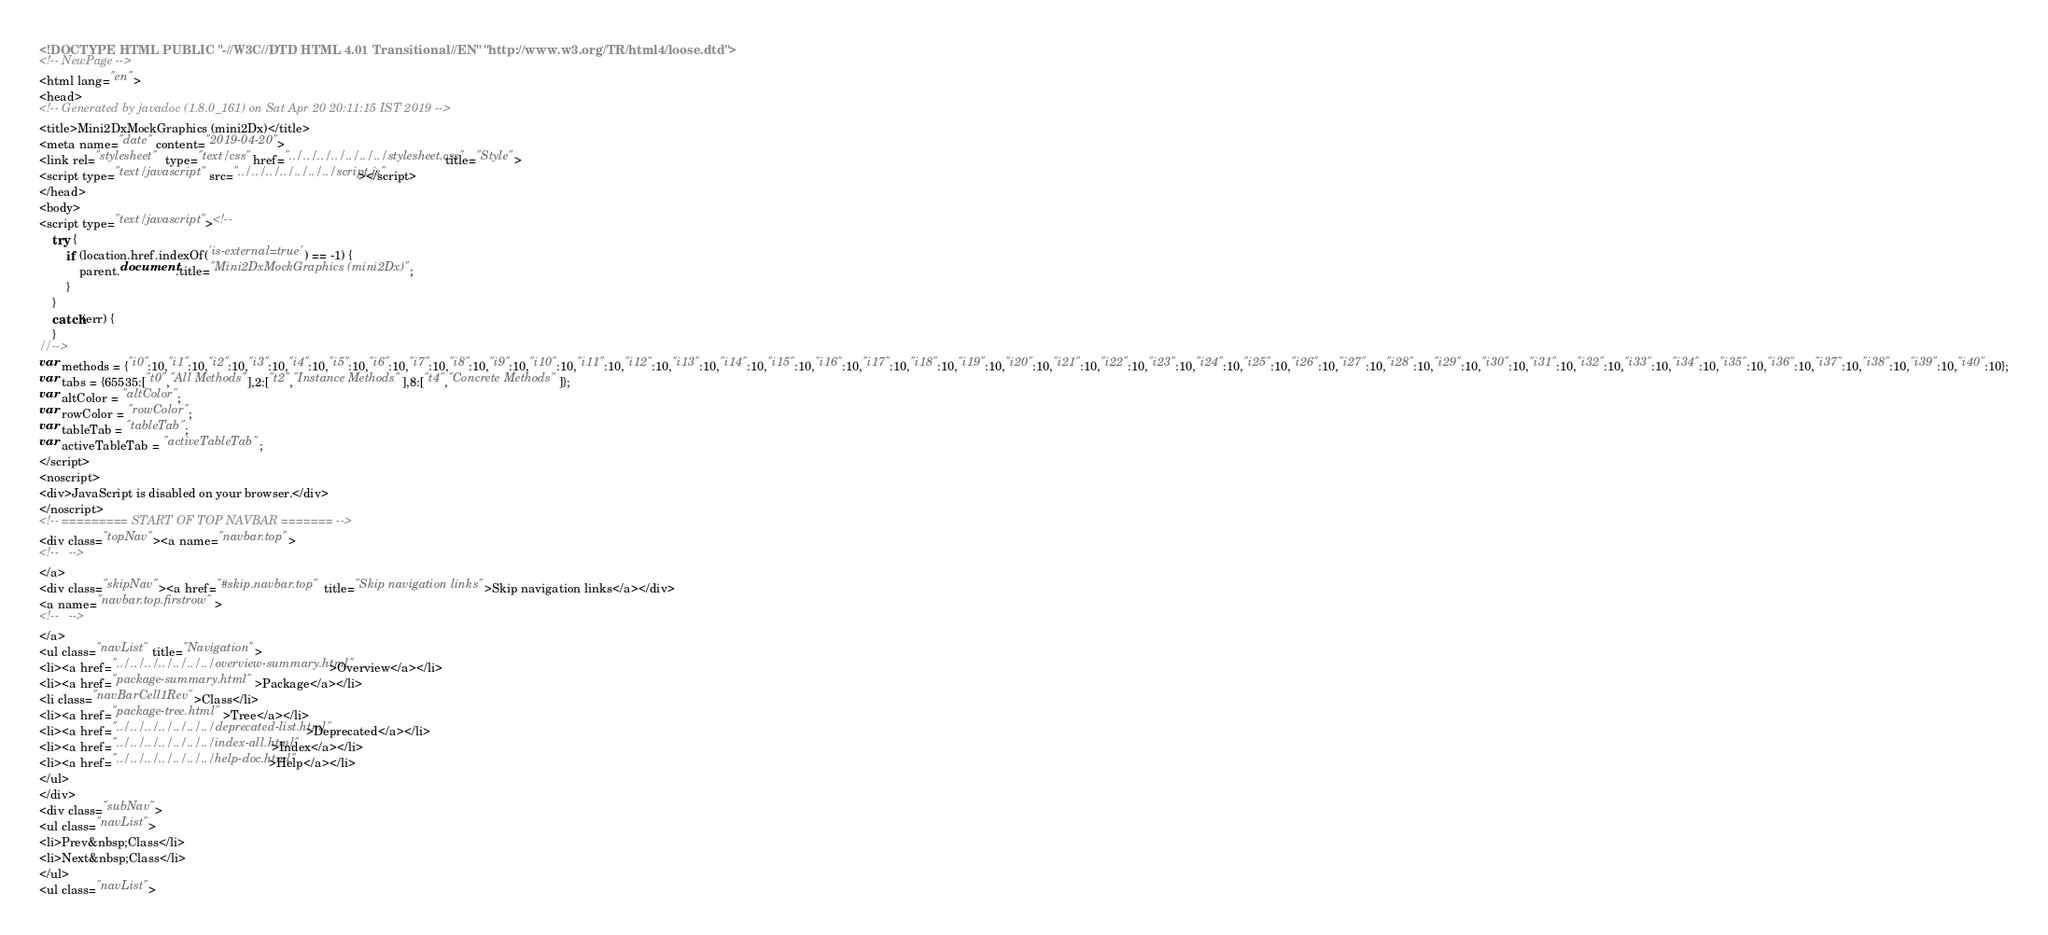Convert code to text. <code><loc_0><loc_0><loc_500><loc_500><_HTML_><!DOCTYPE HTML PUBLIC "-//W3C//DTD HTML 4.01 Transitional//EN" "http://www.w3.org/TR/html4/loose.dtd">
<!-- NewPage -->
<html lang="en">
<head>
<!-- Generated by javadoc (1.8.0_161) on Sat Apr 20 20:11:15 IST 2019 -->
<title>Mini2DxMockGraphics (mini2Dx)</title>
<meta name="date" content="2019-04-20">
<link rel="stylesheet" type="text/css" href="../../../../../../../stylesheet.css" title="Style">
<script type="text/javascript" src="../../../../../../../script.js"></script>
</head>
<body>
<script type="text/javascript"><!--
    try {
        if (location.href.indexOf('is-external=true') == -1) {
            parent.document.title="Mini2DxMockGraphics (mini2Dx)";
        }
    }
    catch(err) {
    }
//-->
var methods = {"i0":10,"i1":10,"i2":10,"i3":10,"i4":10,"i5":10,"i6":10,"i7":10,"i8":10,"i9":10,"i10":10,"i11":10,"i12":10,"i13":10,"i14":10,"i15":10,"i16":10,"i17":10,"i18":10,"i19":10,"i20":10,"i21":10,"i22":10,"i23":10,"i24":10,"i25":10,"i26":10,"i27":10,"i28":10,"i29":10,"i30":10,"i31":10,"i32":10,"i33":10,"i34":10,"i35":10,"i36":10,"i37":10,"i38":10,"i39":10,"i40":10};
var tabs = {65535:["t0","All Methods"],2:["t2","Instance Methods"],8:["t4","Concrete Methods"]};
var altColor = "altColor";
var rowColor = "rowColor";
var tableTab = "tableTab";
var activeTableTab = "activeTableTab";
</script>
<noscript>
<div>JavaScript is disabled on your browser.</div>
</noscript>
<!-- ========= START OF TOP NAVBAR ======= -->
<div class="topNav"><a name="navbar.top">
<!--   -->
</a>
<div class="skipNav"><a href="#skip.navbar.top" title="Skip navigation links">Skip navigation links</a></div>
<a name="navbar.top.firstrow">
<!--   -->
</a>
<ul class="navList" title="Navigation">
<li><a href="../../../../../../../overview-summary.html">Overview</a></li>
<li><a href="package-summary.html">Package</a></li>
<li class="navBarCell1Rev">Class</li>
<li><a href="package-tree.html">Tree</a></li>
<li><a href="../../../../../../../deprecated-list.html">Deprecated</a></li>
<li><a href="../../../../../../../index-all.html">Index</a></li>
<li><a href="../../../../../../../help-doc.html">Help</a></li>
</ul>
</div>
<div class="subNav">
<ul class="navList">
<li>Prev&nbsp;Class</li>
<li>Next&nbsp;Class</li>
</ul>
<ul class="navList"></code> 